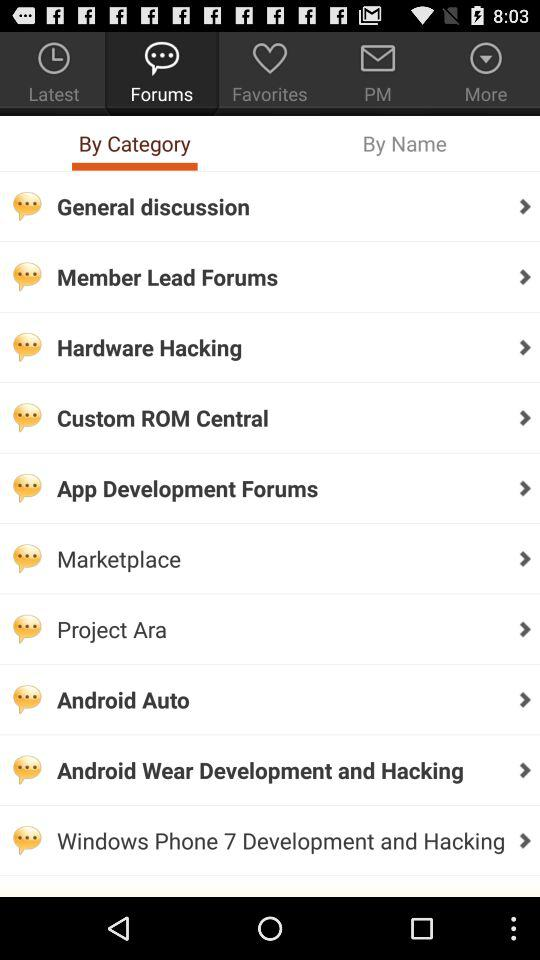Which tab is selected? The selected tabs are "Forums" and "By Category". 